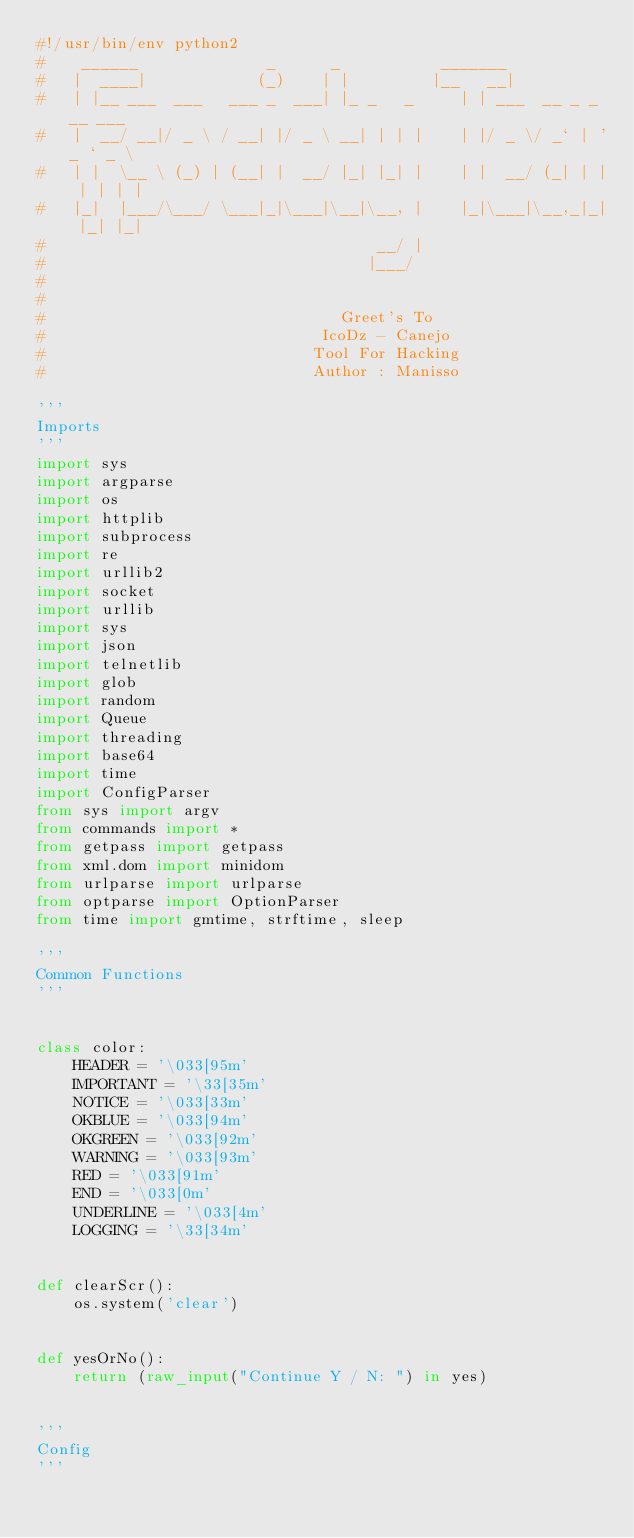<code> <loc_0><loc_0><loc_500><loc_500><_Python_>#!/usr/bin/env python2
#    ______              _      _           _______
#   |  ____|            (_)    | |         |__   __|
#   | |__ ___  ___   ___ _  ___| |_ _   _     | | ___  __ _ _ __ ___
#   |  __/ __|/ _ \ / __| |/ _ \ __| | | |    | |/ _ \/ _` | '_ ` _ \
#   | |  \__ \ (_) | (__| |  __/ |_| |_| |    | |  __/ (_| | | | | | |
#   |_|  |___/\___/ \___|_|\___|\__|\__, |    |_|\___|\__,_|_| |_| |_|
#                                    __/ |
#                                   |___/
#
#
#                                Greet's To
#                              IcoDz - Canejo
#                             Tool For Hacking
#                             Author : Manisso

'''
Imports
'''
import sys
import argparse
import os
import httplib
import subprocess
import re
import urllib2
import socket
import urllib
import sys
import json
import telnetlib
import glob
import random
import Queue
import threading
import base64
import time
import ConfigParser
from sys import argv
from commands import *
from getpass import getpass
from xml.dom import minidom
from urlparse import urlparse
from optparse import OptionParser
from time import gmtime, strftime, sleep

'''
Common Functions
'''


class color:
    HEADER = '\033[95m'
    IMPORTANT = '\33[35m'
    NOTICE = '\033[33m'
    OKBLUE = '\033[94m'
    OKGREEN = '\033[92m'
    WARNING = '\033[93m'
    RED = '\033[91m'
    END = '\033[0m'
    UNDERLINE = '\033[4m'
    LOGGING = '\33[34m'


def clearScr():
    os.system('clear')


def yesOrNo():
    return (raw_input("Continue Y / N: ") in yes)


'''
Config
'''</code> 